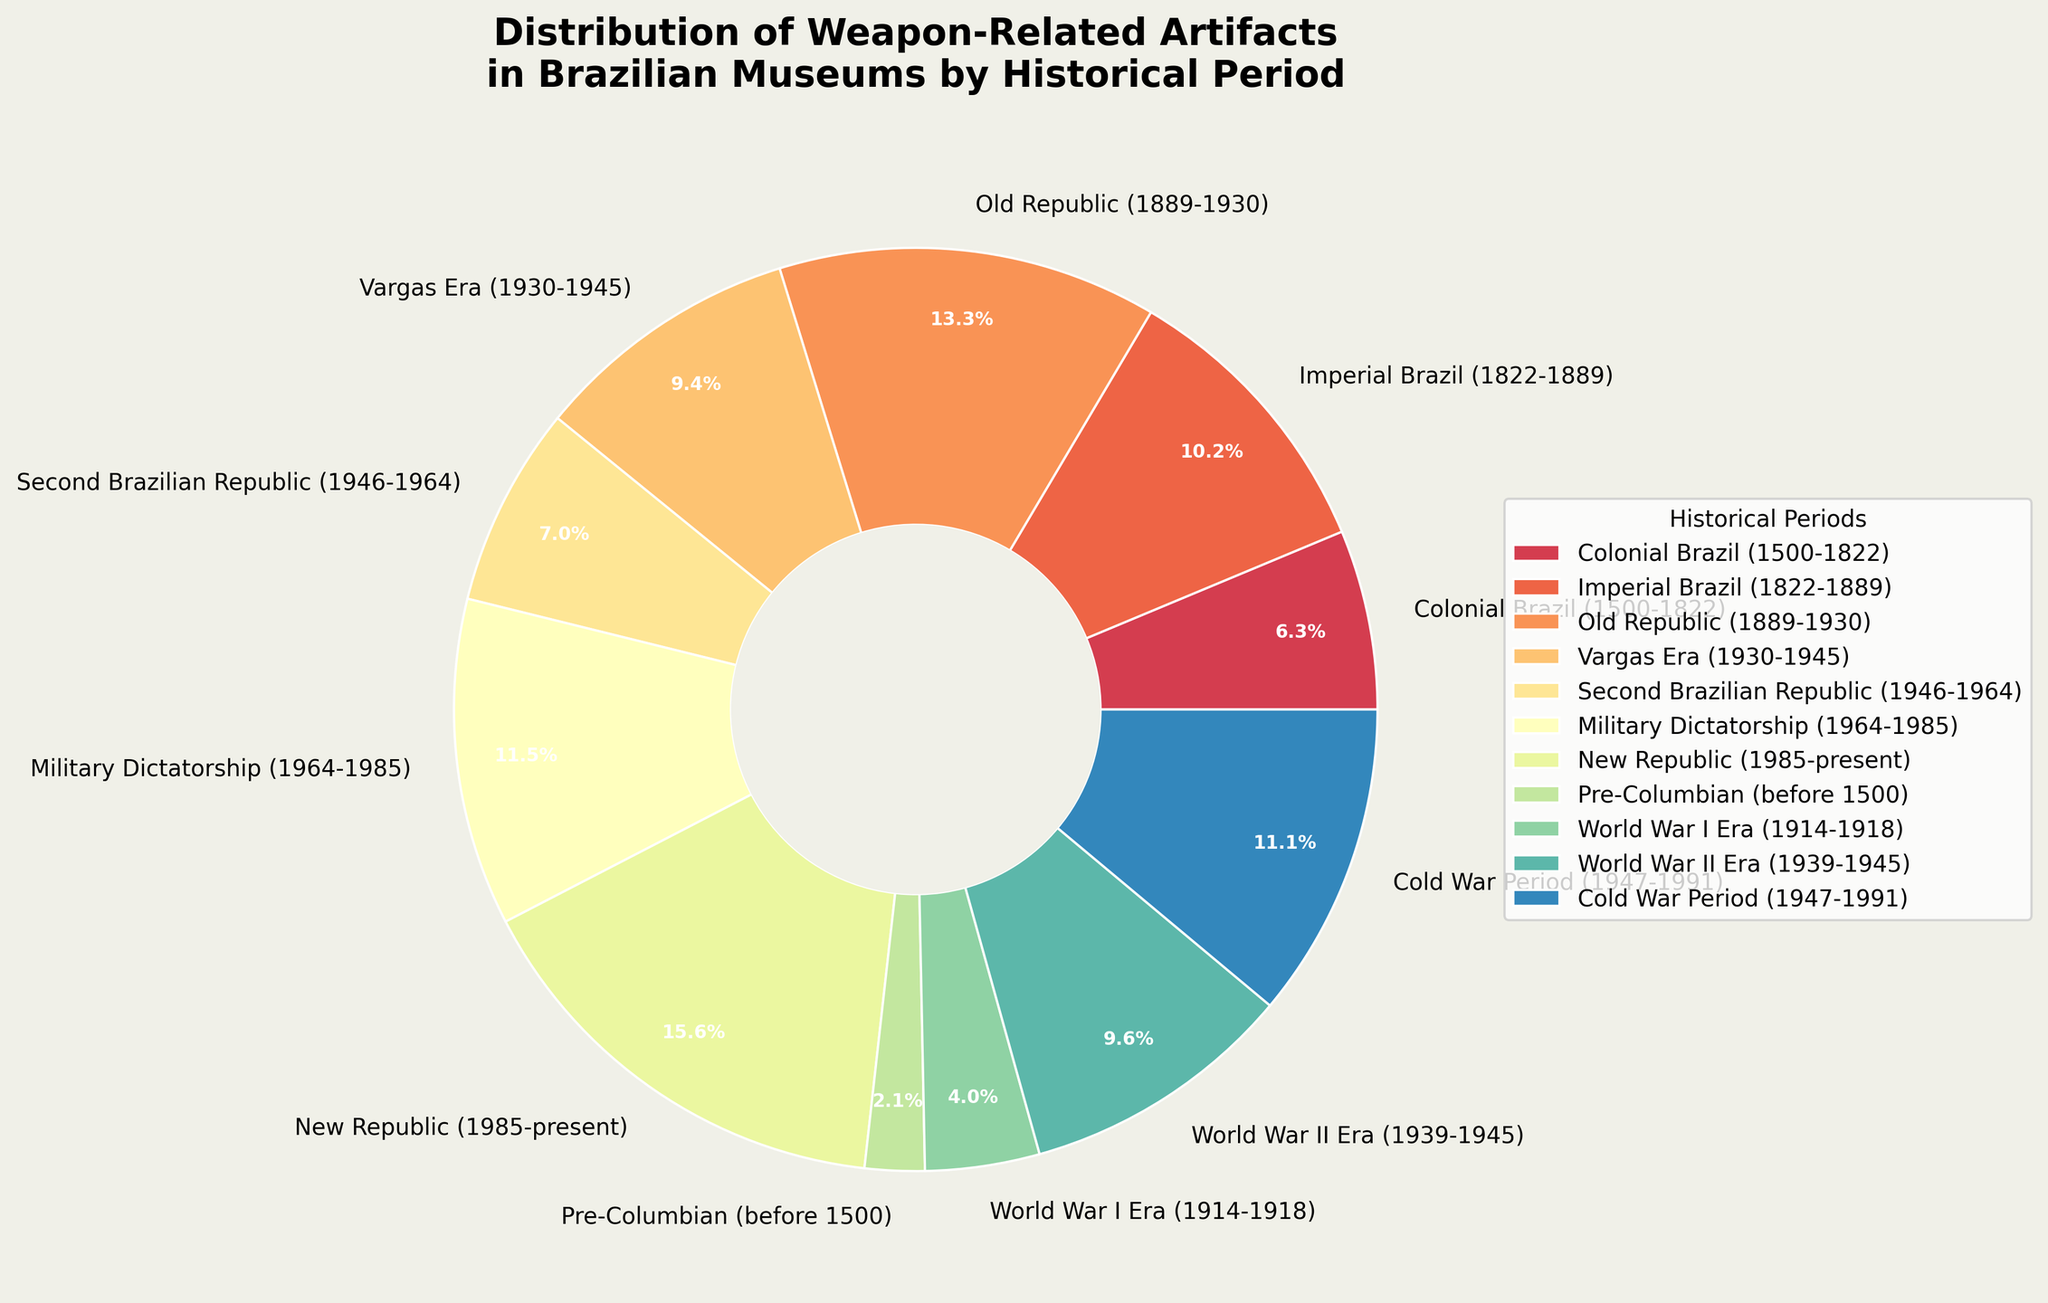Which historical period has the largest distribution of weapon-related artifacts in Brazilian museums? According to the pie chart, the "New Republic (1985-present)" section occupies the largest area, indicating the largest distribution of artifacts.
Answer: New Republic (1985-present) What is the total percentage of weapon-related artifacts from the World War I Era and World War II Era combined? The World War I Era shows 245 artifacts and the World War II Era shows 587 artifacts. Combined they have 832 artifacts. Using the percentage values from the pie chart, sum them to find the total percentage.
Answer: 14.7% Which historical period has fewer artifacts, the Pre-Columbian or the Vargas Era? The pie chart shows that the Pre-Columbian period has a smaller slice compared to the Vargas Era. The Pre-Columbian period has 128 artifacts, while the Vargas Era has 573 artifacts.
Answer: Pre-Columbian How do the number of artifacts from the Military Dictatorship compare to those from the Cold War Period? The Military Dictatorship period has 701 artifacts, while the Cold War Period has 678 artifacts. Compare these numbers to see that the Military Dictatorship has more artifacts.
Answer: Military Dictatorship What is the total number of weapon-related artifacts from the Colonial Brazil and Imperial Brazil periods? Add the number of artifacts from Colonial Brazil (385) to those from Imperial Brazil (624): \(385 + 624 = 1009\).
Answer: 1009 What percentage of the total artifacts are from the Old Republic period? The Old Republic period shows 812 artifacts. To find the percentage, divide 812 by the total number of artifacts and multiply by 100. The percentage is shown directly in the pie chart for reference.
Answer: 12.5% Are there more artifacts from the Second Brazilian Republic or the World War II Era? Compare the slices representing these two periods. The Second Brazilian Republic has 429 artifacts while the World War II Era has 587 artifacts. Therefore, the World War II Era period has more artifacts.
Answer: World War II Era Which historical period’s artifacts occupy the smallest portion of the chart? The smallest slice of the pie chart corresponds to the Pre-Columbian period indicating it has the smallest portion of artifacts (128 artifacts).
Answer: Pre-Columbian What is the difference in the number of artifacts between the New Republic and the Cold War Period? Subtract the number of Cold War Period artifacts (678) from the number of New Republic artifacts (956): \(956 - 678 = 278\).
Answer: 278 